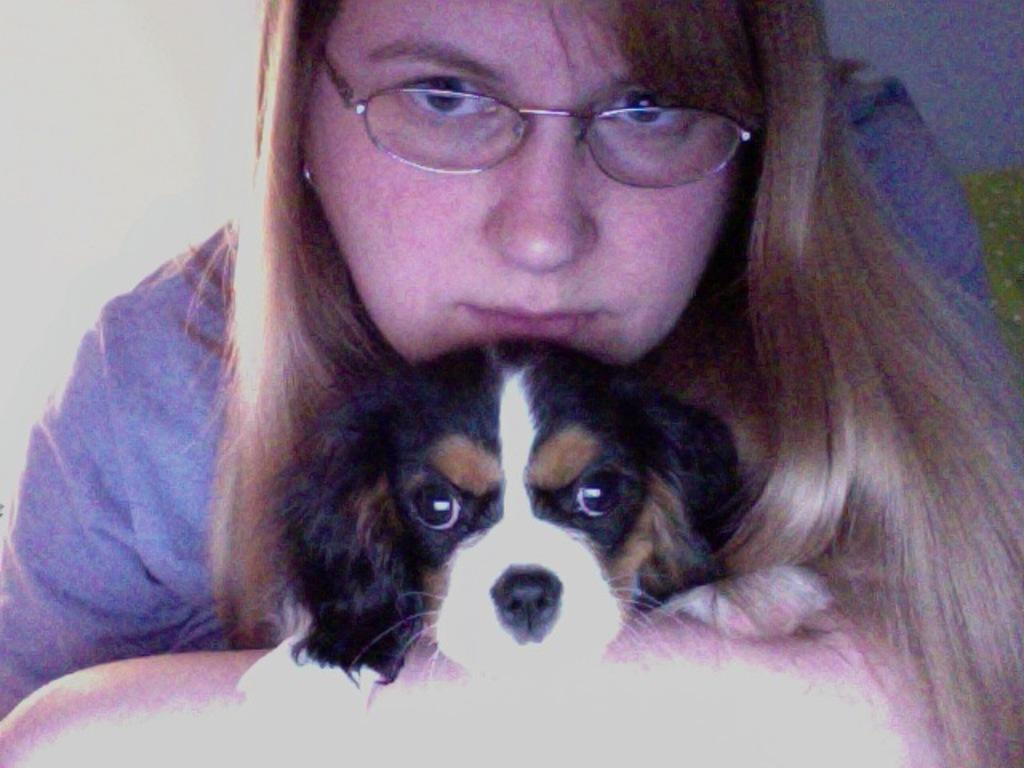What type of animal is in the image? There is a dog in the image. Who is present in the image besides the dog? There is a woman in the image. What can be seen in the background of the image? There is a wall in the background of the image. What type of approval does the dog need to give in the image? There is no indication in the image that the dog needs to give any approval. 